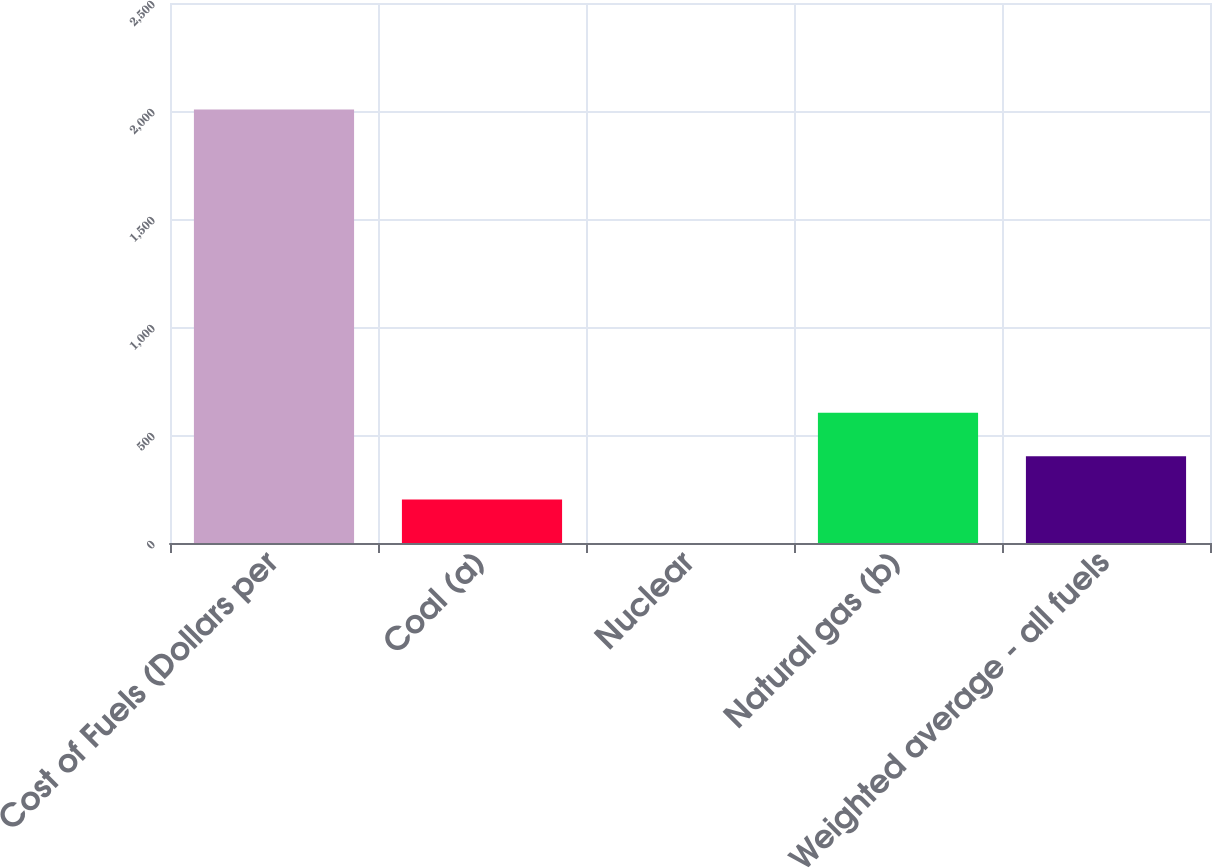Convert chart to OTSL. <chart><loc_0><loc_0><loc_500><loc_500><bar_chart><fcel>Cost of Fuels (Dollars per<fcel>Coal (a)<fcel>Nuclear<fcel>Natural gas (b)<fcel>Weighted average - all fuels<nl><fcel>2007<fcel>201.14<fcel>0.49<fcel>602.44<fcel>401.79<nl></chart> 